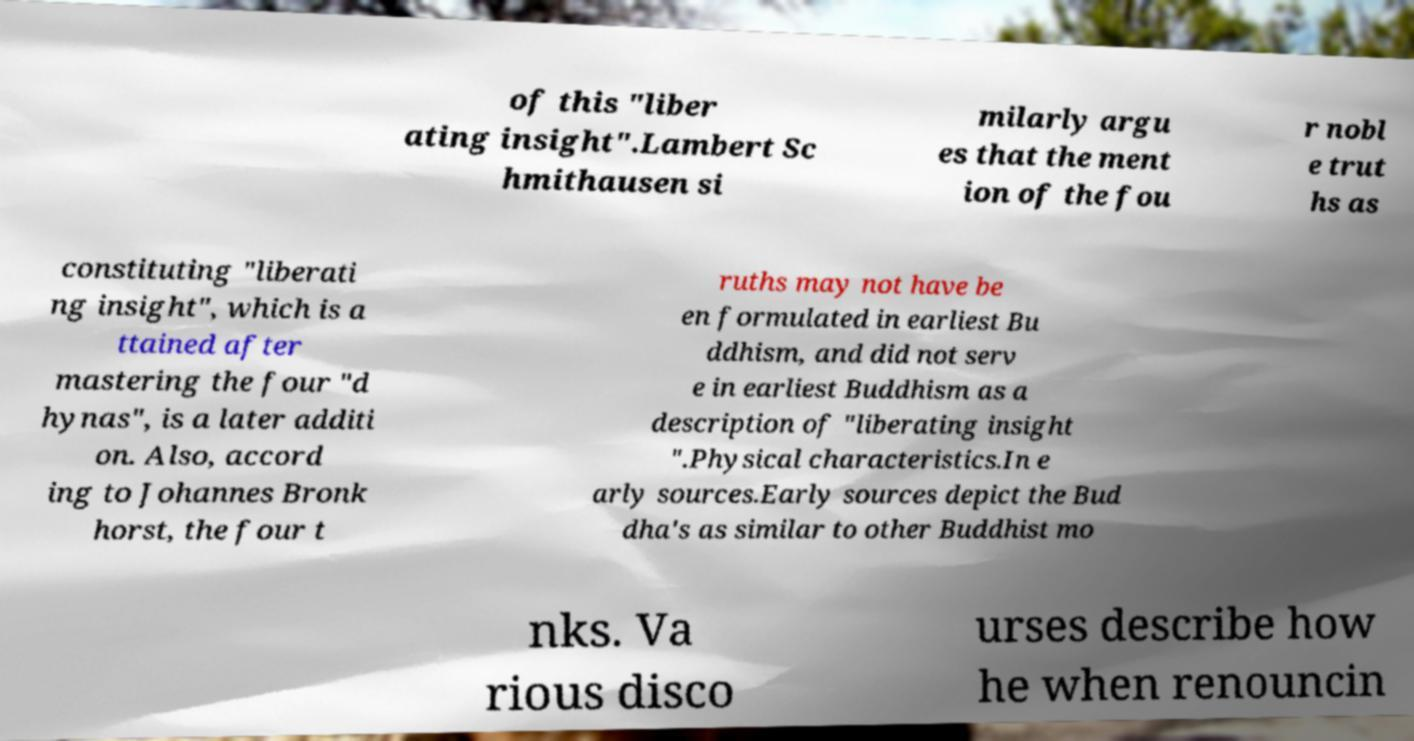Could you assist in decoding the text presented in this image and type it out clearly? of this "liber ating insight".Lambert Sc hmithausen si milarly argu es that the ment ion of the fou r nobl e trut hs as constituting "liberati ng insight", which is a ttained after mastering the four "d hynas", is a later additi on. Also, accord ing to Johannes Bronk horst, the four t ruths may not have be en formulated in earliest Bu ddhism, and did not serv e in earliest Buddhism as a description of "liberating insight ".Physical characteristics.In e arly sources.Early sources depict the Bud dha's as similar to other Buddhist mo nks. Va rious disco urses describe how he when renouncin 